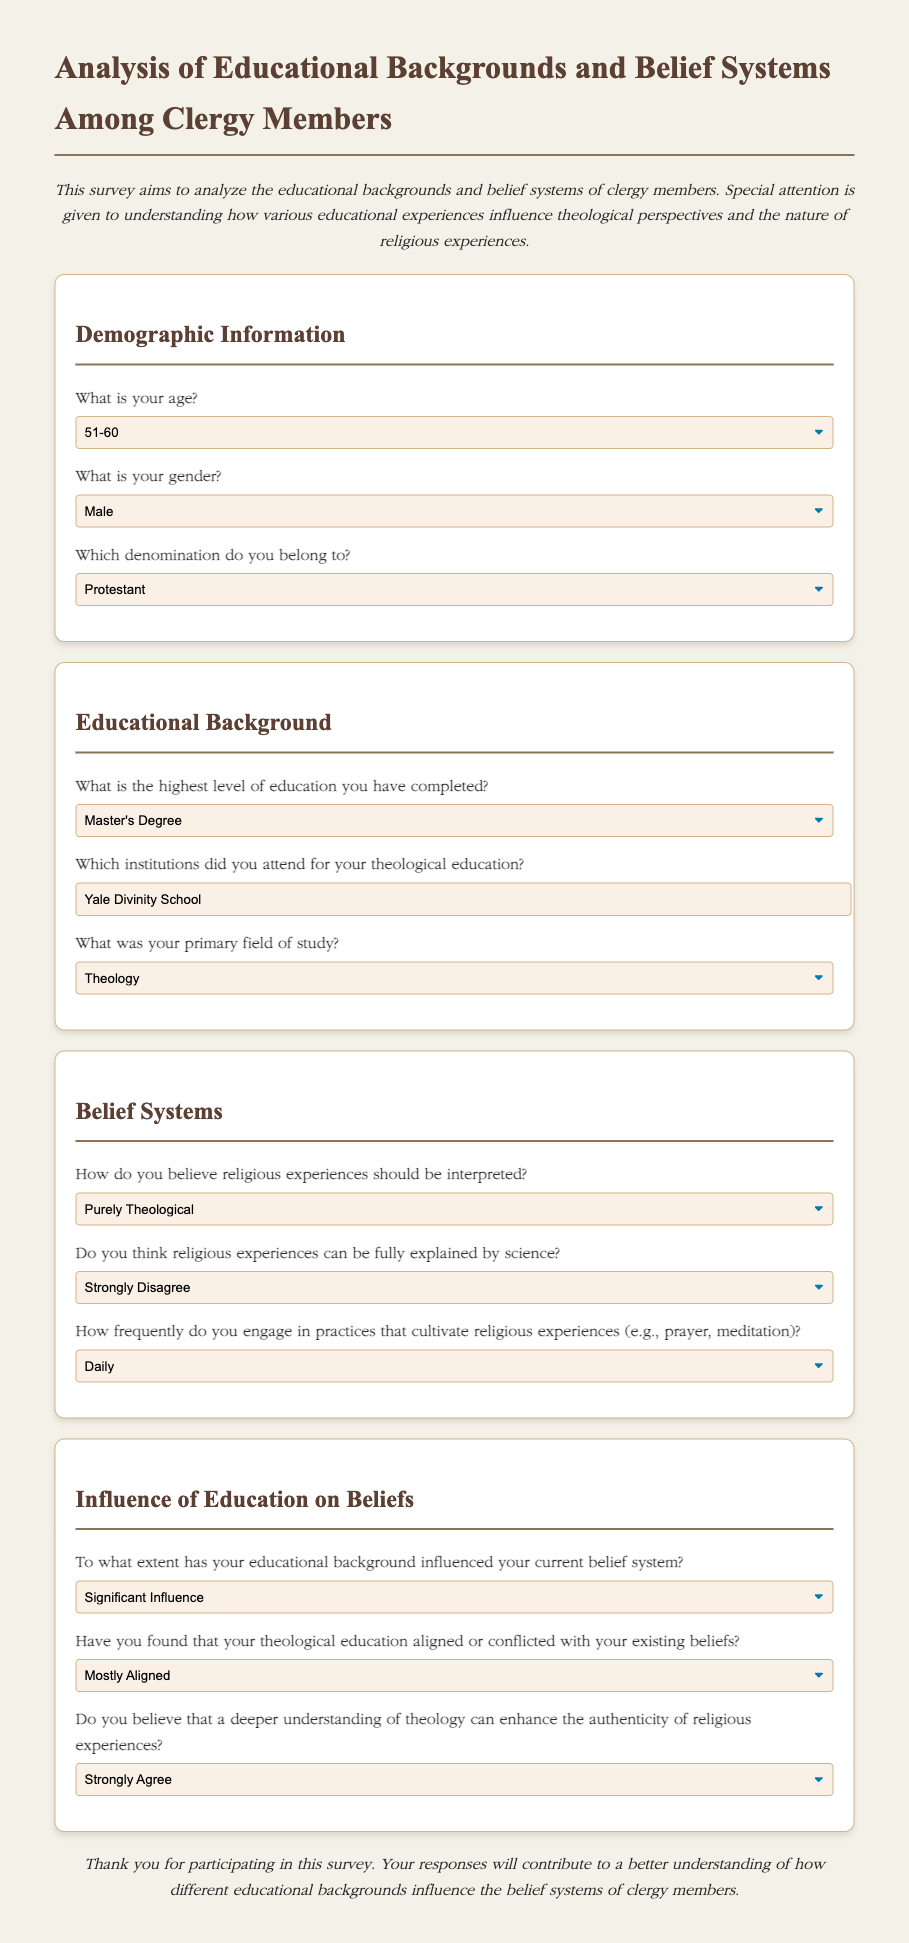What is your age? The survey includes a question about the age of the respondent, which has options listed.
Answer: 51-60 What is the highest level of education you have completed? One of the survey questions asks about the highest level of education attained by clergy members, with several options provided.
Answer: Master's Degree What denomination do you belong to? The survey requests information about the respondent's religious affiliation, specifically their denomination.
Answer: Protestant How frequently do you engage in practices that cultivate religious experiences? A question focused on the frequency of engagement in spiritual practices is included in the belief systems section of the survey.
Answer: Daily To what extent has your educational background influenced your current belief system? This question assesses the impact of the respondent's education on their beliefs.
Answer: Significant Influence How do you believe religious experiences should be interpreted? The survey asks for the respondent's perspective on interpreting religious experiences, providing multiple choice options.
Answer: Purely Theological Have you found that your theological education aligned or conflicted with your existing beliefs? This question investigates the relationship between theological education and existing beliefs of the respondents.
Answer: Mostly Aligned Do you think religious experiences can be fully explained by science? The survey prompts respondents to express their views on whether science can account for religious experiences.
Answer: Strongly Disagree Do you believe that a deeper understanding of theology can enhance the authenticity of religious experiences? This question assesses the belief in the potential impact of theological understanding on the perception of religious experiences.
Answer: Strongly Agree 